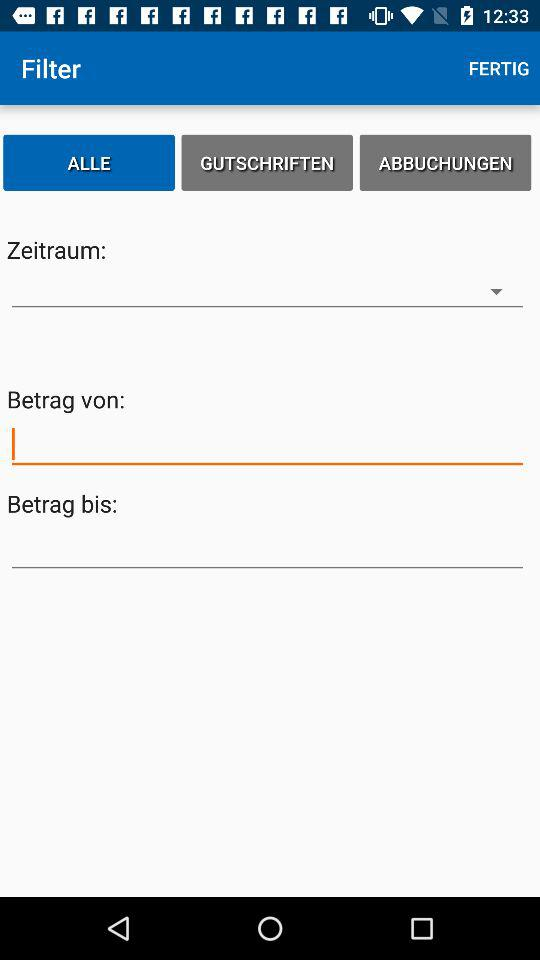How many input fields are there for the filter?
Answer the question using a single word or phrase. 3 